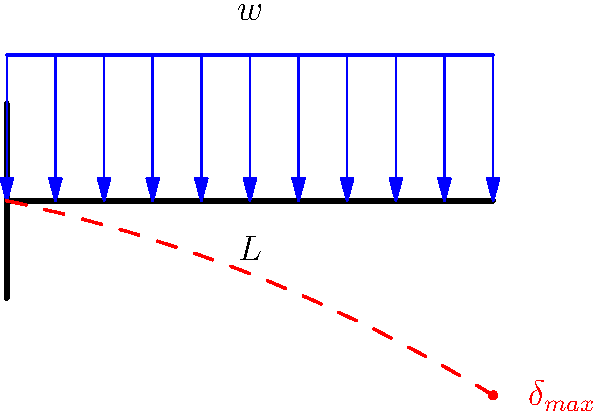A startup in New York City is developing an innovative cantilever-based structural system for urban infrastructure projects. They've approached you for investment advice, presenting a problem involving a uniformly loaded cantilever beam. The beam has length $L$ and is subjected to a uniformly distributed load $w$ per unit length. What is the maximum deflection $\delta_{max}$ at the free end of the beam in terms of $w$, $L$, Young's modulus $E$, and the moment of inertia $I$? To solve this problem, we'll follow these steps:

1) The differential equation for the deflection of a beam is:

   $$\frac{d^2y}{dx^2} = \frac{M(x)}{EI}$$

   where $M(x)$ is the bending moment at any point $x$ along the beam.

2) For a cantilever beam with uniformly distributed load $w$, the bending moment at any point $x$ is:

   $$M(x) = \frac{w}{2}(L^2 - x^2)$$

3) Substituting this into the differential equation:

   $$\frac{d^2y}{dx^2} = \frac{w}{2EI}(L^2 - x^2)$$

4) Integrating twice:

   $$\frac{dy}{dx} = \frac{w}{2EI}(L^2x - \frac{x^3}{3}) + C_1$$

   $$y = \frac{w}{2EI}(\frac{L^2x^2}{2} - \frac{x^4}{12}) + C_1x + C_2$$

5) Using boundary conditions: at $x=0$, $y=0$ and $\frac{dy}{dx}=0$, we get $C_1=C_2=0$.

6) The maximum deflection occurs at the free end, where $x=L$:

   $$\delta_{max} = y(L) = \frac{w}{2EI}(\frac{L^4}{2} - \frac{L^4}{12}) = \frac{wL^4}{8EI}$$

Therefore, the maximum deflection at the free end of the cantilever beam is $\frac{wL^4}{8EI}$.
Answer: $\frac{wL^4}{8EI}$ 